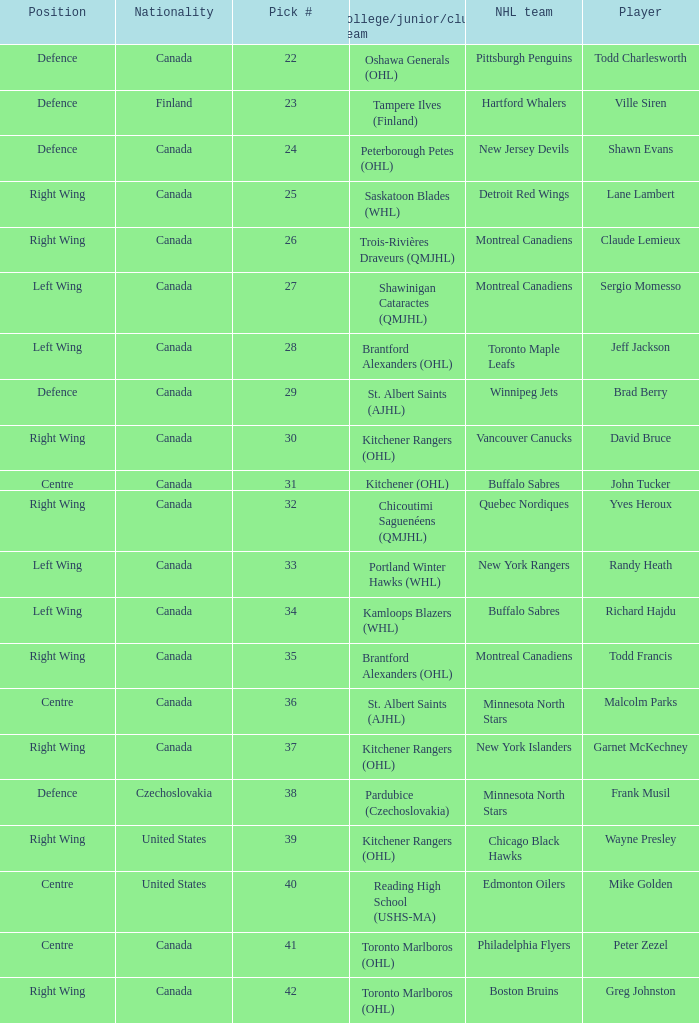What is the nationality when the player is randy heath? Canada. 